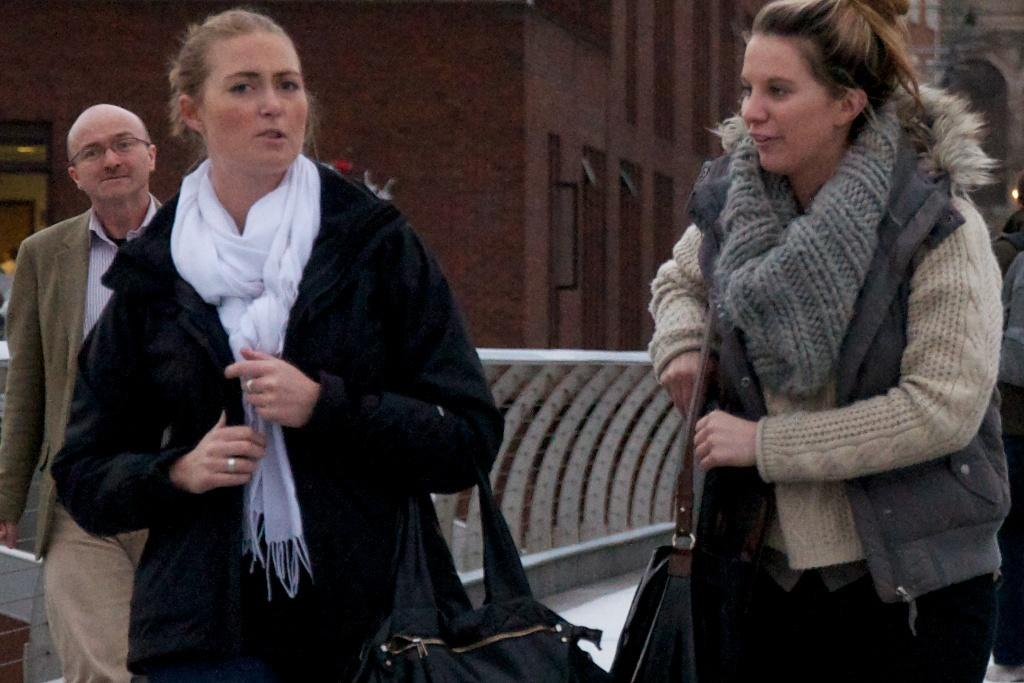How many people are in the image? There are three persons in the image. Where are the persons located? The persons are on the road. What can be seen in the background of the image? There is a fence, buildings, a door, and windows in the background of the image. What type of chain is being used by the persons in the image? There is no chain visible in the image. 